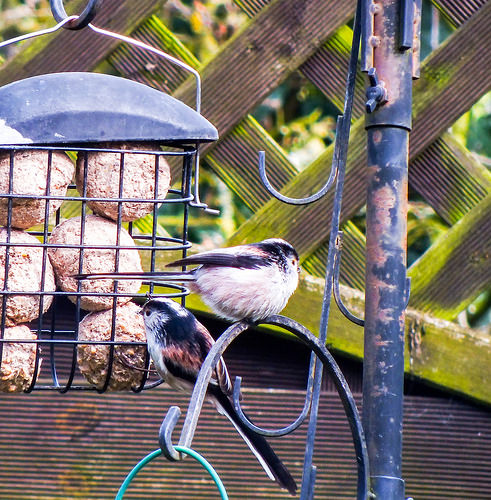<image>
Can you confirm if the bird is in front of the feeder? Yes. The bird is positioned in front of the feeder, appearing closer to the camera viewpoint. 